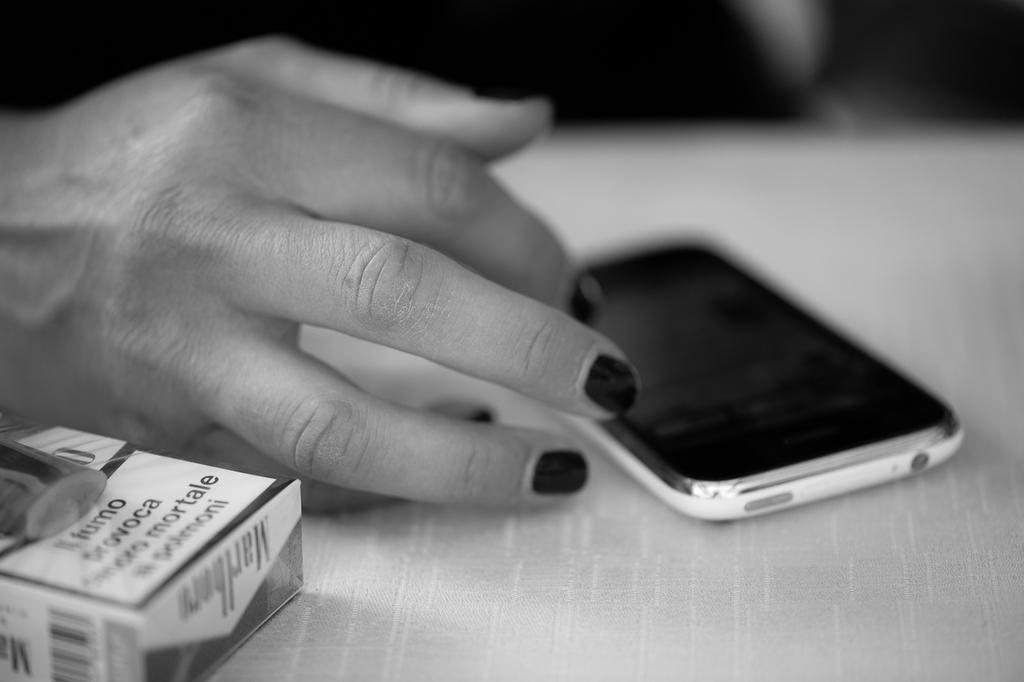<image>
Offer a succinct explanation of the picture presented. a pack of marlboro  cigarettes next to someones hand on a counter 